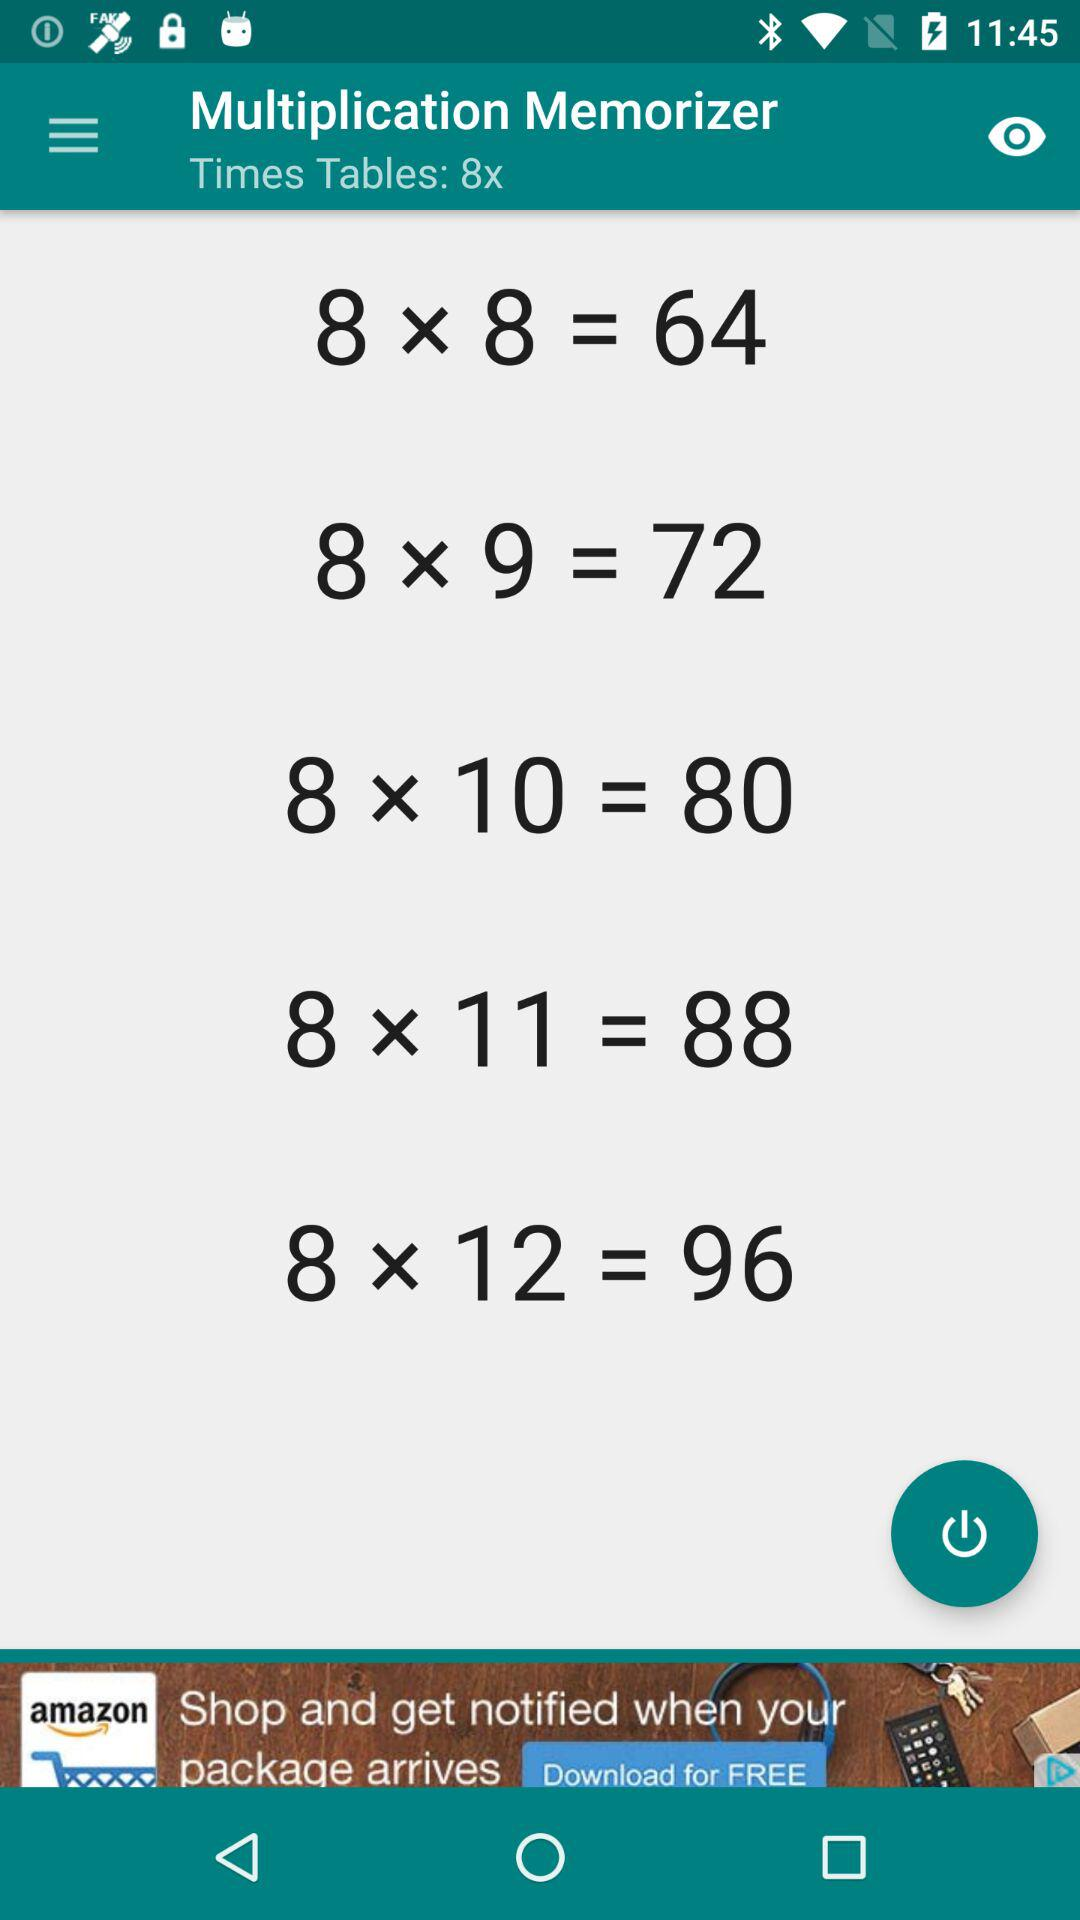What is the application name? The application name is "Multiplication Memorizer". 